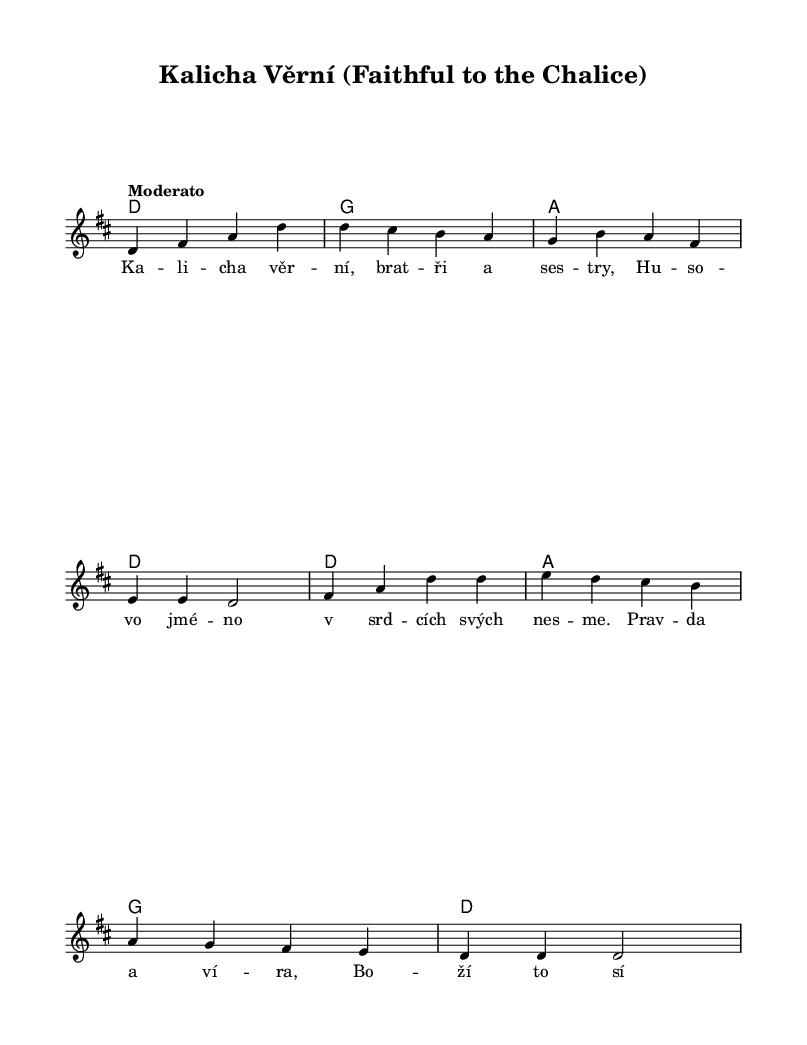What is the key signature of this music? The key signature is indicated by the sharp signs at the beginning of the staff. In this case, there are two sharps, which corresponds to D major.
Answer: D major What is the time signature of this piece? The time signature is shown at the beginning of the score and indicates that there are four beats per measure, which is represented by the numbers 4 over 4.
Answer: 4/4 What is the tempo marking for this song? The tempo is indicated above the staff with the word “Moderato,” which signifies a moderate speed of music performance.
Answer: Moderato How many measures are present in the melody? Counting the groups of notes separated by vertical lines (bars) in the melody section reveals that there are eight measures in total.
Answer: 8 What does the title of the piece signify? The title "Kalicha Věrní" translates to "Faithful to the Chalice," reflecting themes tied to the Hussite faith and the legacy of Jan Hus, dedicating this song to the principles he stood for.
Answer: Faithful to the Chalice Identify the first note of the melody. The lowest note in the melody section starts on the note D in the second octave, as indicated at the beginning of the score.
Answer: D What kind of harmony is used in this piece? The harmony is structured using basic chords within the key signature, specifically root position triads including D, G, and A, which are typical in folk music.
Answer: Triadic harmony 